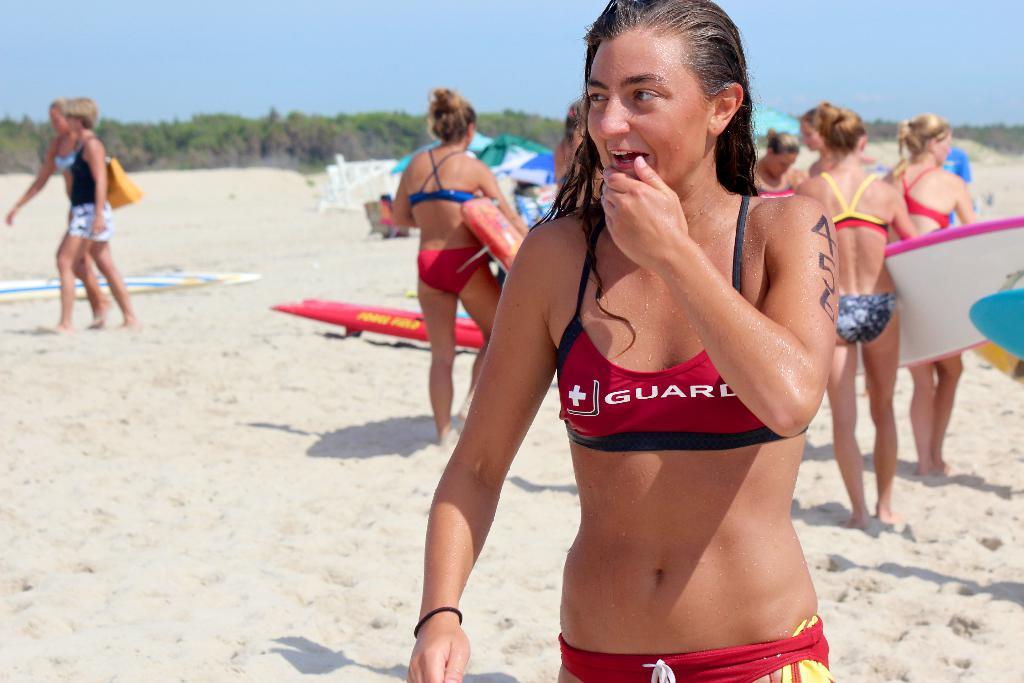What does her top say her job is?
Your response must be concise. Guard. What number is on her arm?
Make the answer very short. 456. 